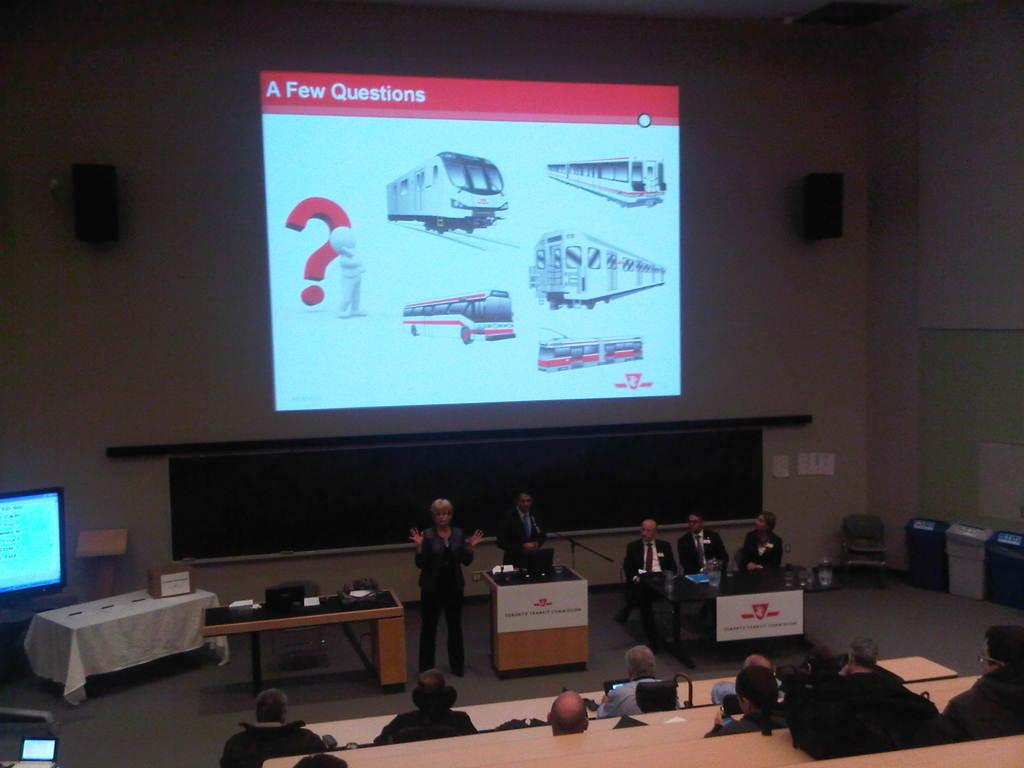<image>
Provide a brief description of the given image. A woman is giving a presentation and her slide shows trains and says A Few Questions. 